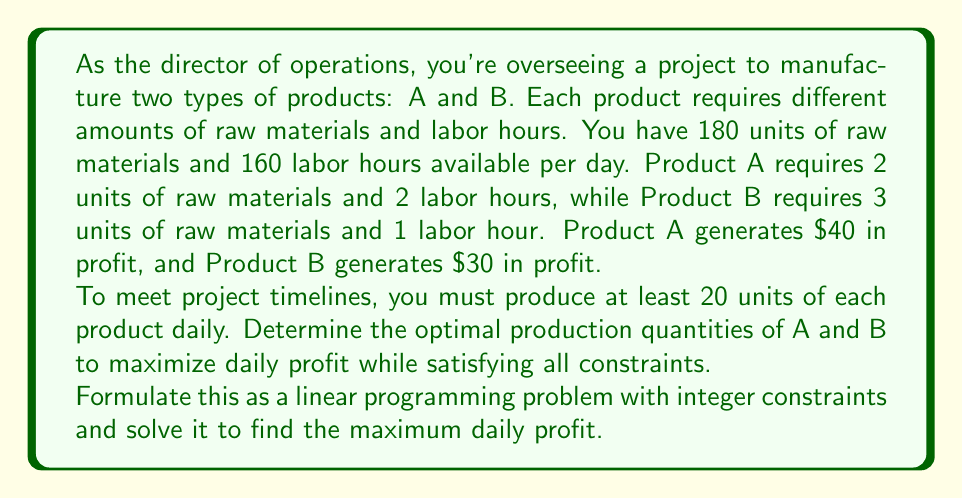Can you solve this math problem? Let's approach this step-by-step:

1) Define variables:
   Let $x$ = number of units of Product A
   Let $y$ = number of units of Product B

2) Objective function (maximize profit):
   $$ \text{Maximize } Z = 40x + 30y $$

3) Constraints:
   a) Raw material constraint: $2x + 3y \leq 180$
   b) Labor hour constraint: $2x + y \leq 160$
   c) Minimum production constraints: $x \geq 20$ and $y \geq 20$
   d) Integer constraints: $x$ and $y$ must be integers

4) Formulate the complete linear programming problem:
   $$ \text{Maximize } Z = 40x + 30y $$
   $$ \text{Subject to:} $$
   $$ 2x + 3y \leq 180 $$
   $$ 2x + y \leq 160 $$
   $$ x \geq 20 $$
   $$ y \geq 20 $$
   $$ x, y \in \mathbb{Z}^+ $$

5) Solve using the graphical method or software:
   The feasible region is bounded by the constraints. The optimal solution will be at one of the corner points of this region.

6) Corner points to consider:
   (20, 20), (20, 46.67), (60, 20), (50, 26.67)

7) Evaluate the objective function at these points:
   (20, 20): $Z = 40(20) + 30(20) = 1400$
   (20, 46): $Z = 40(20) + 30(46) = 2180$
   (60, 20): $Z = 40(60) + 30(20) = 3000$
   (50, 26): $Z = 40(50) + 30(26) = 2780$

8) The optimal integer solution is (60, 20), producing 60 units of A and 20 units of B.

9) Maximum daily profit: $40(60) + 30(20) = 2400 + 600 = 3000$
Answer: The optimal production quantities are 60 units of Product A and 20 units of Product B, yielding a maximum daily profit of $3000. 